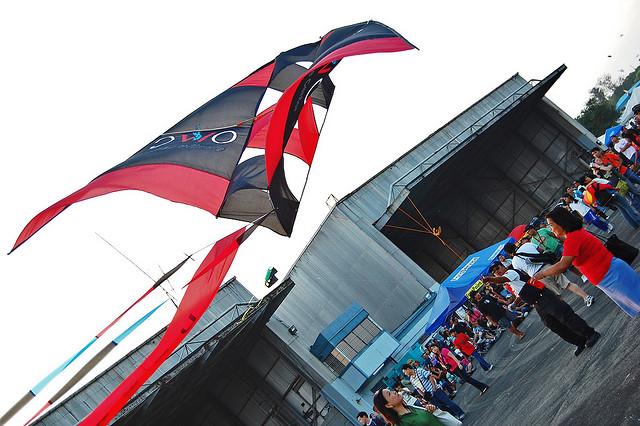What color is the kite?
Be succinct. Red black white. Is this photo straight?
Concise answer only. No. What are the buildings made out of?
Keep it brief. Concrete. 